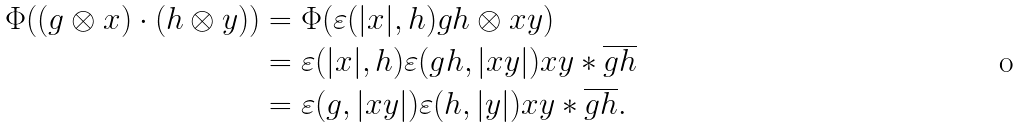<formula> <loc_0><loc_0><loc_500><loc_500>\Phi ( ( g \otimes x ) \cdot ( h \otimes y ) ) & = \Phi ( \varepsilon ( | x | , h ) g h \otimes x y ) \\ & = \varepsilon ( | x | , h ) \varepsilon ( g h , | x y | ) x y * \overline { g h } \\ & = \varepsilon ( g , | x y | ) \varepsilon ( h , | y | ) x y * \overline { g h } .</formula> 